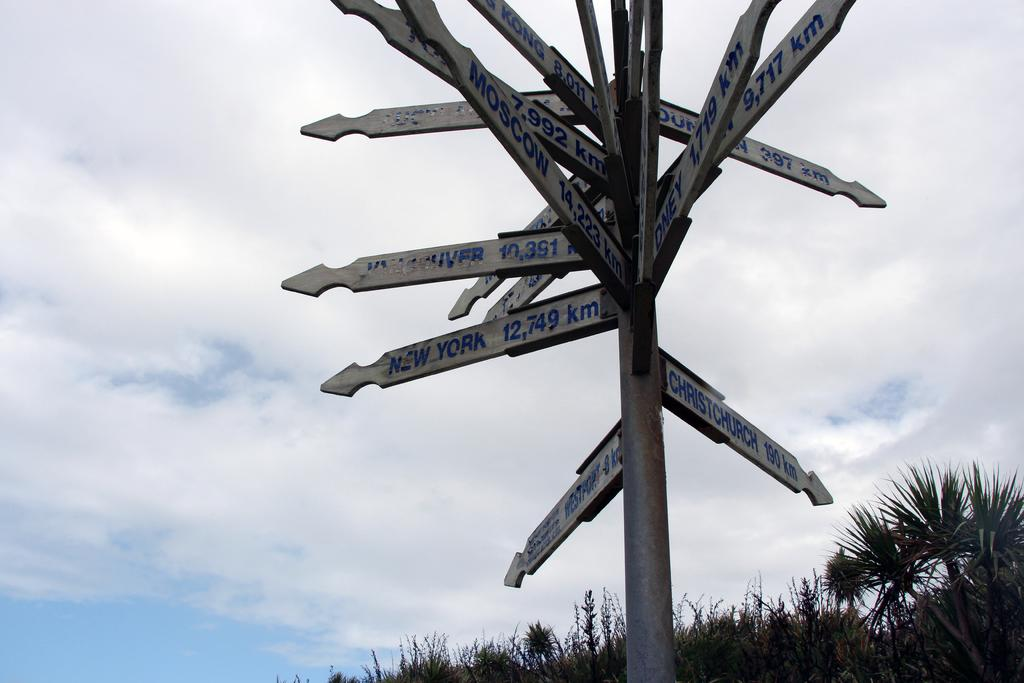<image>
Share a concise interpretation of the image provided. A sign points in multiple directions, giving the distance to various locations including New York. 